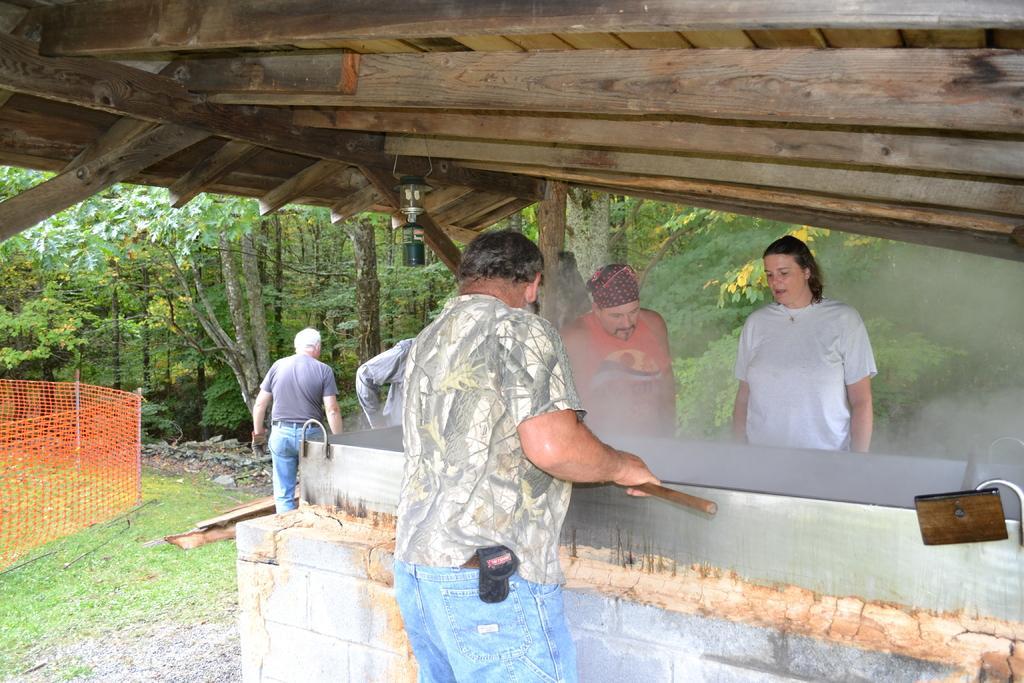Could you give a brief overview of what you see in this image? In front of the picture, we see a man is standing and he is holding a wooden stick. In front of him, we see a steel object. Beside that, we see three people are standing. Beside them, we see a man in the grey T-shirt is standing. At the bottom, we see the grass, stones and the wooden sticks. On the left side, we see the poles and the net in red color. At the top, we see the light and the roof of the wooden shed. There are trees in the background. 